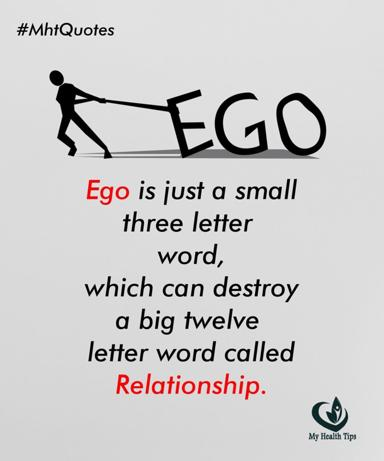Can you explain the significance of the color choices in the image? The image predominantly features stark black and white colors, which could symbolize the clear, often harsh reality of conflicts driven by ego. Black, representing the ego, suggests the absorption of all emotional light, while white around 'Relationship' could represent purity and the potential for positive connections, now under threat due to the overshadowing black ego. How does this color symbolism contribute to the overall message of the quote? The contrasting colors intensify the visual and thematic conflict between ego and relationship. This stark opposition accentuates the message that ego, if not checked, can be a destructive force, swallowing up the virtues and potentials of a healthy relationship, visually reinforcing the quote's warning against letting ego control interpersonal dynamics. 